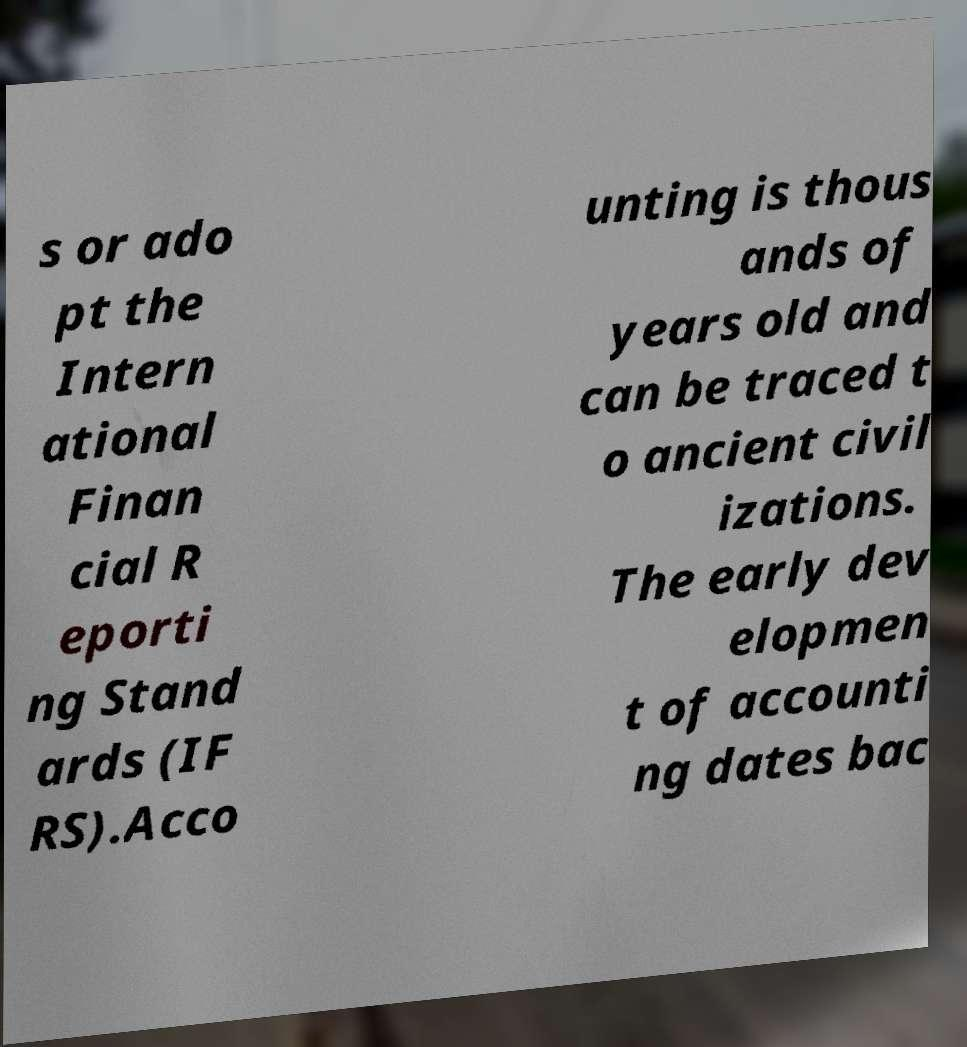I need the written content from this picture converted into text. Can you do that? s or ado pt the Intern ational Finan cial R eporti ng Stand ards (IF RS).Acco unting is thous ands of years old and can be traced t o ancient civil izations. The early dev elopmen t of accounti ng dates bac 